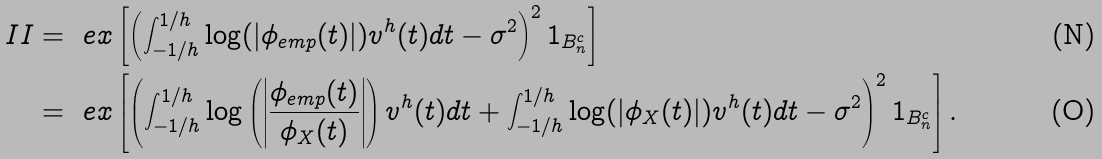<formula> <loc_0><loc_0><loc_500><loc_500>I I & = \ e x \left [ \left ( \int _ { - 1 / h } ^ { 1 / h } \log ( | \phi _ { e m p } ( t ) | ) v ^ { h } ( t ) d t - \sigma ^ { 2 } \right ) ^ { 2 } 1 _ { B _ { n } ^ { c } } \right ] \\ & = \ e x \left [ \left ( \int _ { - 1 / h } ^ { 1 / h } \log \left ( \left | \frac { \phi _ { e m p } ( t ) } { \phi _ { X } ( t ) } \right | \right ) v ^ { h } ( t ) d t + \int _ { - 1 / h } ^ { 1 / h } \log ( | \phi _ { X } ( t ) | ) v ^ { h } ( t ) d t - \sigma ^ { 2 } \right ) ^ { 2 } 1 _ { B _ { n } ^ { c } } \right ] .</formula> 